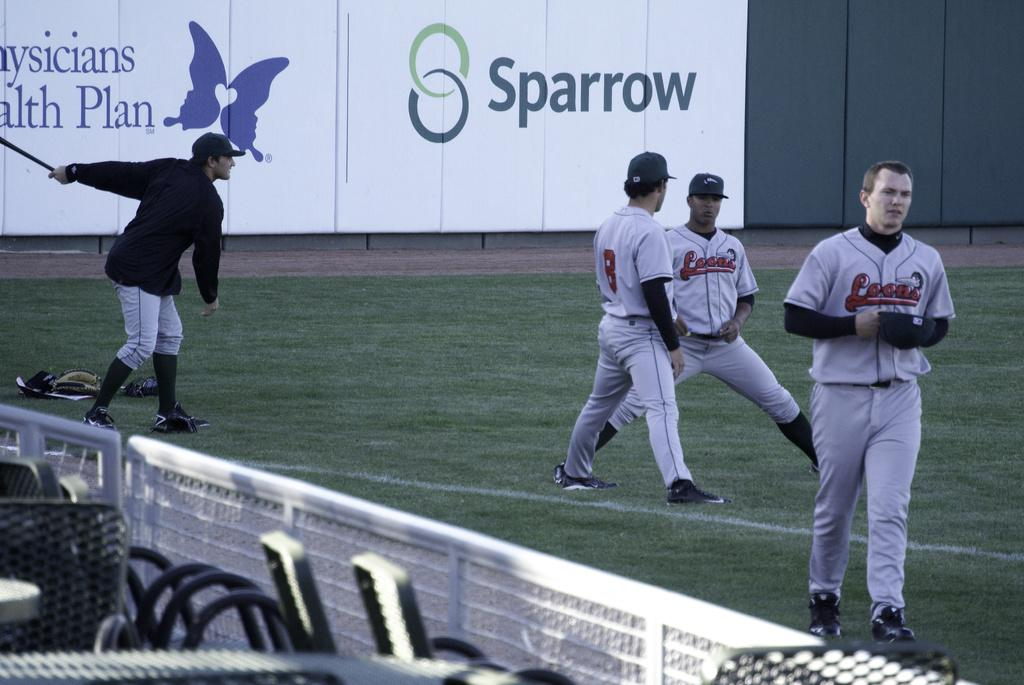<image>
Create a compact narrative representing the image presented. a baseball team with a sparrow advertisement behind them 